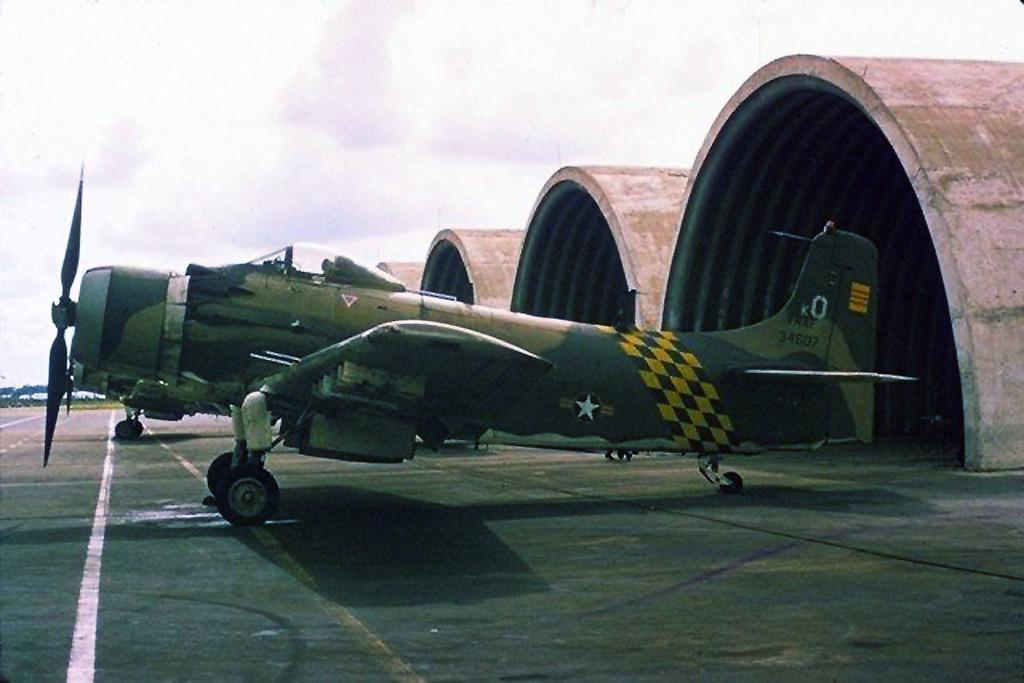<image>
Share a concise interpretation of the image provided. an old plane with 34607 on the tail fin sits near some hangars 